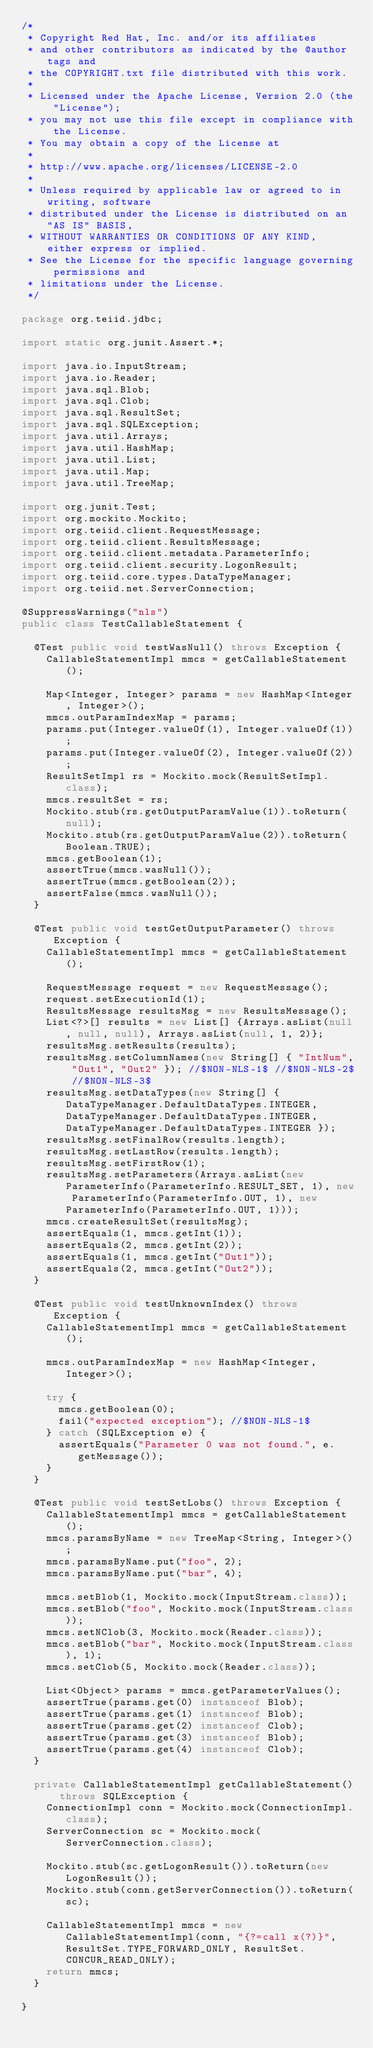Convert code to text. <code><loc_0><loc_0><loc_500><loc_500><_Java_>/*
 * Copyright Red Hat, Inc. and/or its affiliates
 * and other contributors as indicated by the @author tags and
 * the COPYRIGHT.txt file distributed with this work.
 *
 * Licensed under the Apache License, Version 2.0 (the "License");
 * you may not use this file except in compliance with the License.
 * You may obtain a copy of the License at
 *
 * http://www.apache.org/licenses/LICENSE-2.0
 *
 * Unless required by applicable law or agreed to in writing, software
 * distributed under the License is distributed on an "AS IS" BASIS,
 * WITHOUT WARRANTIES OR CONDITIONS OF ANY KIND, either express or implied.
 * See the License for the specific language governing permissions and
 * limitations under the License.
 */

package org.teiid.jdbc;

import static org.junit.Assert.*;

import java.io.InputStream;
import java.io.Reader;
import java.sql.Blob;
import java.sql.Clob;
import java.sql.ResultSet;
import java.sql.SQLException;
import java.util.Arrays;
import java.util.HashMap;
import java.util.List;
import java.util.Map;
import java.util.TreeMap;

import org.junit.Test;
import org.mockito.Mockito;
import org.teiid.client.RequestMessage;
import org.teiid.client.ResultsMessage;
import org.teiid.client.metadata.ParameterInfo;
import org.teiid.client.security.LogonResult;
import org.teiid.core.types.DataTypeManager;
import org.teiid.net.ServerConnection;

@SuppressWarnings("nls")
public class TestCallableStatement {
	
	@Test public void testWasNull() throws Exception {
		CallableStatementImpl mmcs = getCallableStatement();
		
		Map<Integer, Integer> params = new HashMap<Integer, Integer>();
		mmcs.outParamIndexMap = params;
		params.put(Integer.valueOf(1), Integer.valueOf(1));
		params.put(Integer.valueOf(2), Integer.valueOf(2));
		ResultSetImpl rs = Mockito.mock(ResultSetImpl.class);
		mmcs.resultSet = rs;
		Mockito.stub(rs.getOutputParamValue(1)).toReturn(null);
		Mockito.stub(rs.getOutputParamValue(2)).toReturn(Boolean.TRUE);
		mmcs.getBoolean(1);
		assertTrue(mmcs.wasNull());
		assertTrue(mmcs.getBoolean(2));
		assertFalse(mmcs.wasNull());
	}
	
	@Test public void testGetOutputParameter() throws Exception {
		CallableStatementImpl mmcs = getCallableStatement();
		
		RequestMessage request = new RequestMessage();
		request.setExecutionId(1);
		ResultsMessage resultsMsg = new ResultsMessage();
		List<?>[] results = new List[] {Arrays.asList(null, null, null), Arrays.asList(null, 1, 2)};
		resultsMsg.setResults(results);
		resultsMsg.setColumnNames(new String[] { "IntNum", "Out1", "Out2" }); //$NON-NLS-1$ //$NON-NLS-2$ //$NON-NLS-3$
		resultsMsg.setDataTypes(new String[] { DataTypeManager.DefaultDataTypes.INTEGER, DataTypeManager.DefaultDataTypes.INTEGER, DataTypeManager.DefaultDataTypes.INTEGER }); 
		resultsMsg.setFinalRow(results.length);
		resultsMsg.setLastRow(results.length);
		resultsMsg.setFirstRow(1);
		resultsMsg.setParameters(Arrays.asList(new ParameterInfo(ParameterInfo.RESULT_SET, 1), new ParameterInfo(ParameterInfo.OUT, 1), new ParameterInfo(ParameterInfo.OUT, 1)));
		mmcs.createResultSet(resultsMsg);
		assertEquals(1, mmcs.getInt(1));
		assertEquals(2, mmcs.getInt(2));
		assertEquals(1, mmcs.getInt("Out1"));
		assertEquals(2, mmcs.getInt("Out2"));
	}
	
	@Test public void testUnknownIndex() throws Exception {
		CallableStatementImpl mmcs = getCallableStatement();
		
		mmcs.outParamIndexMap = new HashMap<Integer, Integer>();
		
		try {
			mmcs.getBoolean(0);
			fail("expected exception"); //$NON-NLS-1$
		} catch (SQLException e) {
			assertEquals("Parameter 0 was not found.", e.getMessage());
		}
	}
	
	@Test public void testSetLobs() throws Exception {
		CallableStatementImpl mmcs = getCallableStatement();
		mmcs.paramsByName = new TreeMap<String, Integer>();
		mmcs.paramsByName.put("foo", 2);
		mmcs.paramsByName.put("bar", 4);
		
		mmcs.setBlob(1, Mockito.mock(InputStream.class));
		mmcs.setBlob("foo", Mockito.mock(InputStream.class));
		mmcs.setNClob(3, Mockito.mock(Reader.class));
		mmcs.setBlob("bar", Mockito.mock(InputStream.class), 1);
		mmcs.setClob(5, Mockito.mock(Reader.class));
		
		List<Object> params = mmcs.getParameterValues();
		assertTrue(params.get(0) instanceof Blob);
		assertTrue(params.get(1) instanceof Blob);
		assertTrue(params.get(2) instanceof Clob);
		assertTrue(params.get(3) instanceof Blob);
		assertTrue(params.get(4) instanceof Clob);
	}

	private CallableStatementImpl getCallableStatement() throws SQLException {
		ConnectionImpl conn = Mockito.mock(ConnectionImpl.class);
		ServerConnection sc = Mockito.mock(ServerConnection.class);
		
		Mockito.stub(sc.getLogonResult()).toReturn(new LogonResult());
		Mockito.stub(conn.getServerConnection()).toReturn(sc);
		
		CallableStatementImpl mmcs = new CallableStatementImpl(conn, "{?=call x(?)}", ResultSet.TYPE_FORWARD_ONLY, ResultSet.CONCUR_READ_ONLY);
		return mmcs;
	}

}
</code> 